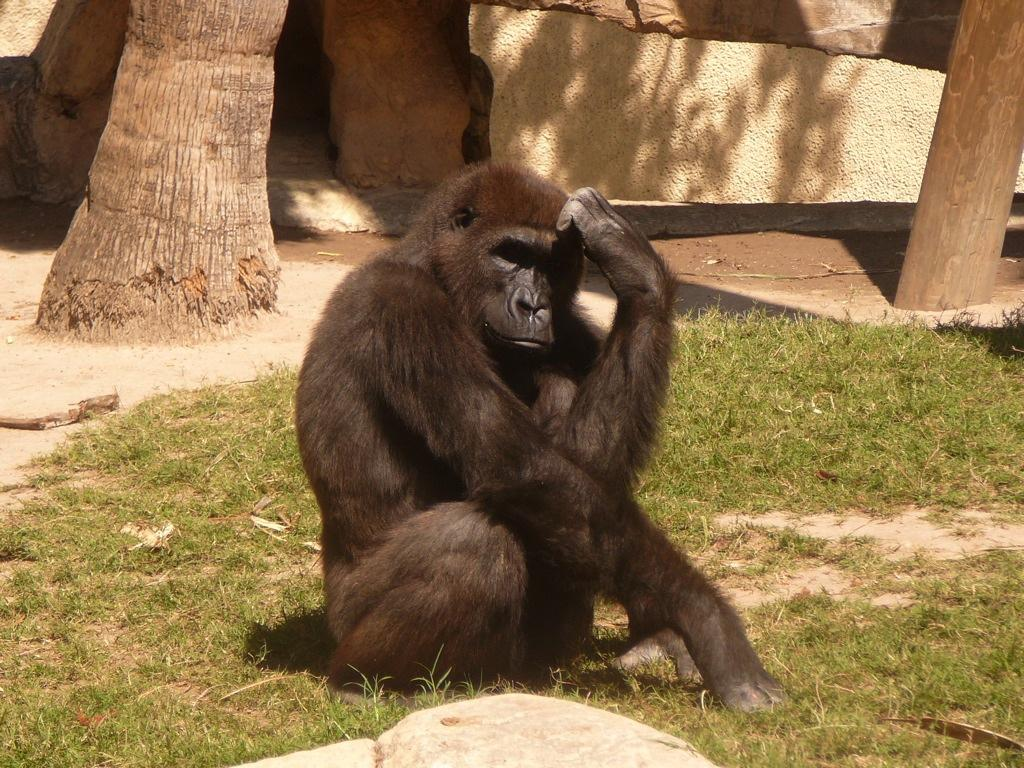What type of vegetation is present in the image? There is grass in the image. What part of a tree can be seen in the image? There is a tree stem in the image. What type of natural formation is present in the image? There are rocks in the image. What type of animal can be seen in the image? There is a black color chimpanzee in the image. What type of cheese is being used to build the dollhouse in the image? There is no cheese or dollhouse present in the image. What type of quiver is the chimpanzee holding in the image? There is no quiver present in the image; the chimpanzee is not holding anything. 